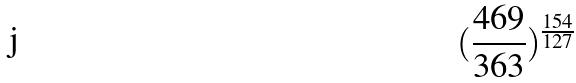<formula> <loc_0><loc_0><loc_500><loc_500>( \frac { 4 6 9 } { 3 6 3 } ) ^ { \frac { 1 5 4 } { 1 2 7 } }</formula> 